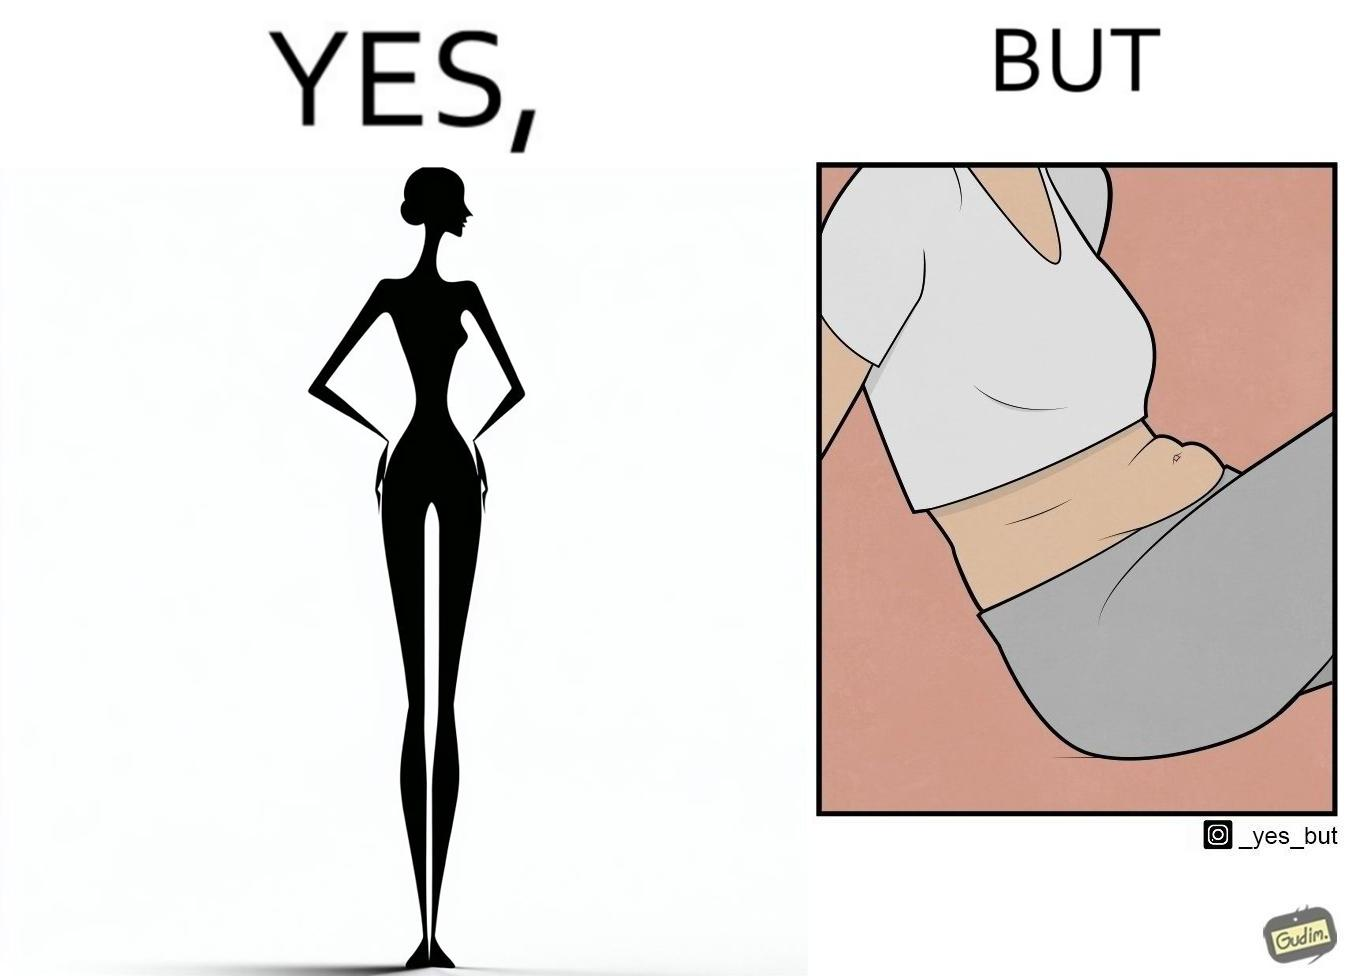Provide a description of this image. the image is funny, as from the front, the woman is apparently slim, but she looks chubby from the side. 